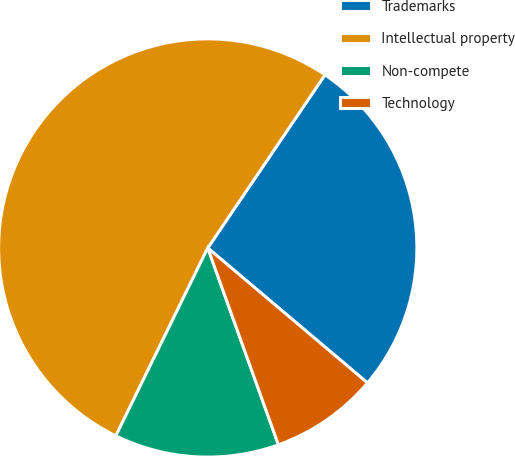<chart> <loc_0><loc_0><loc_500><loc_500><pie_chart><fcel>Trademarks<fcel>Intellectual property<fcel>Non-compete<fcel>Technology<nl><fcel>26.69%<fcel>52.23%<fcel>12.73%<fcel>8.35%<nl></chart> 